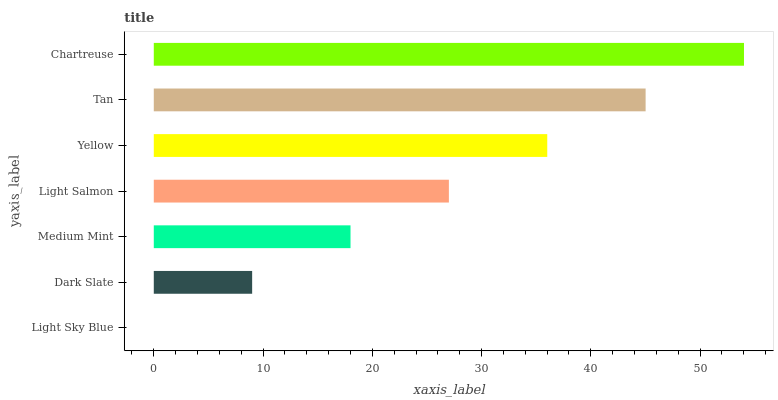Is Light Sky Blue the minimum?
Answer yes or no. Yes. Is Chartreuse the maximum?
Answer yes or no. Yes. Is Dark Slate the minimum?
Answer yes or no. No. Is Dark Slate the maximum?
Answer yes or no. No. Is Dark Slate greater than Light Sky Blue?
Answer yes or no. Yes. Is Light Sky Blue less than Dark Slate?
Answer yes or no. Yes. Is Light Sky Blue greater than Dark Slate?
Answer yes or no. No. Is Dark Slate less than Light Sky Blue?
Answer yes or no. No. Is Light Salmon the high median?
Answer yes or no. Yes. Is Light Salmon the low median?
Answer yes or no. Yes. Is Dark Slate the high median?
Answer yes or no. No. Is Dark Slate the low median?
Answer yes or no. No. 